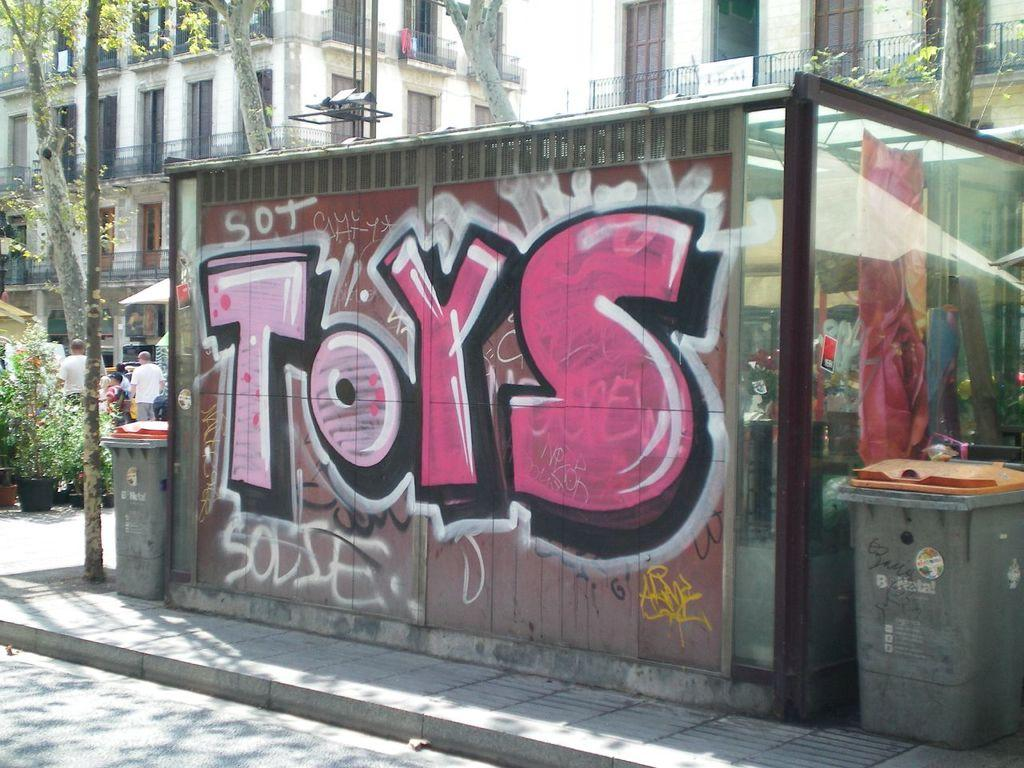Provide a one-sentence caption for the provided image. A greenhouse on a city street is spray painted with the word Toys. 